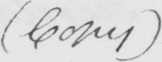Please transcribe the handwritten text in this image. ( Copy ) 